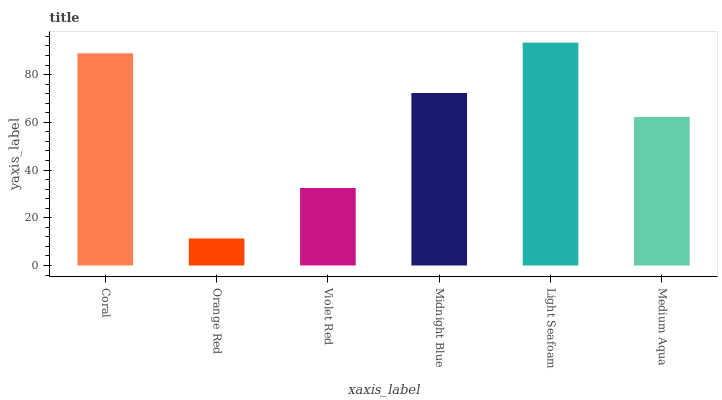Is Violet Red the minimum?
Answer yes or no. No. Is Violet Red the maximum?
Answer yes or no. No. Is Violet Red greater than Orange Red?
Answer yes or no. Yes. Is Orange Red less than Violet Red?
Answer yes or no. Yes. Is Orange Red greater than Violet Red?
Answer yes or no. No. Is Violet Red less than Orange Red?
Answer yes or no. No. Is Midnight Blue the high median?
Answer yes or no. Yes. Is Medium Aqua the low median?
Answer yes or no. Yes. Is Medium Aqua the high median?
Answer yes or no. No. Is Orange Red the low median?
Answer yes or no. No. 